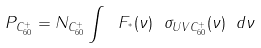<formula> <loc_0><loc_0><loc_500><loc_500>P _ { C _ { 6 0 } ^ { + } } = N _ { C _ { 6 0 } ^ { + } } \int \ F _ { ^ { * } } ( \nu ) \ \sigma _ { U V C _ { 6 0 } ^ { + } } ( \nu ) \ d \nu</formula> 